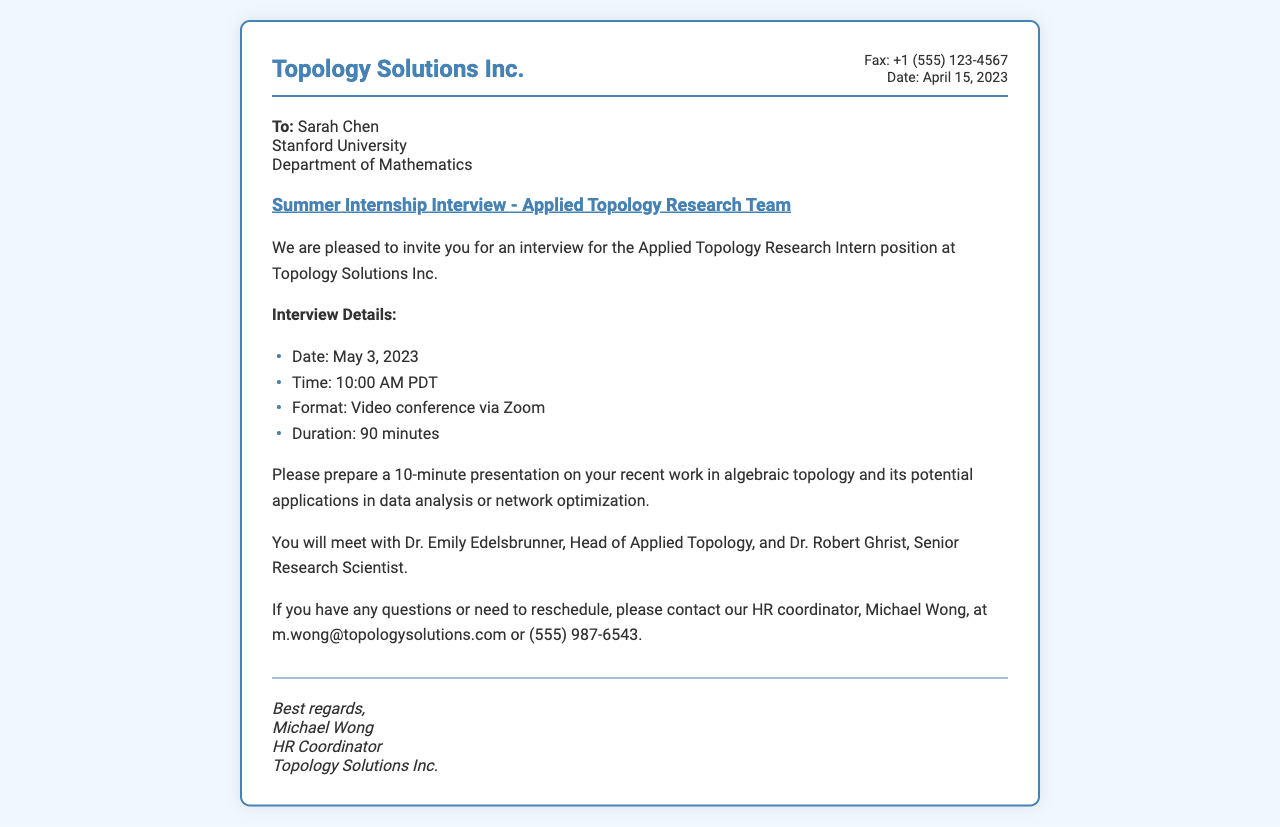What is the name of the company? The company name is clearly stated in the document's header.
Answer: Topology Solutions Inc What is the date of the fax? The date is mentioned in the fax info section at the top of the document.
Answer: April 15, 2023 Who is the recipient of the fax? The recipient's name is provided in the recipient section of the document.
Answer: Sarah Chen What is the interview date? The interview date is specified in the interview details section of the document.
Answer: May 3, 2023 What format will the interview be in? The format for the interview is mentioned under the interview details.
Answer: Video conference via Zoom How long is the interview scheduled to last? The duration of the interview is clearly indicated in the interview details.
Answer: 90 minutes Who will be interviewing Sarah Chen? The names of the interviewers are listed in the body section of the document.
Answer: Dr. Emily Edelsbrunner, Dr. Robert Ghrist What is the purpose of the upcoming meeting? The purpose of the meeting is indicated in the body section of the document.
Answer: Interview for the Applied Topology Research Intern position Who should be contacted for rescheduling? The contact person for rescheduling is mentioned towards the end of the body section.
Answer: Michael Wong 